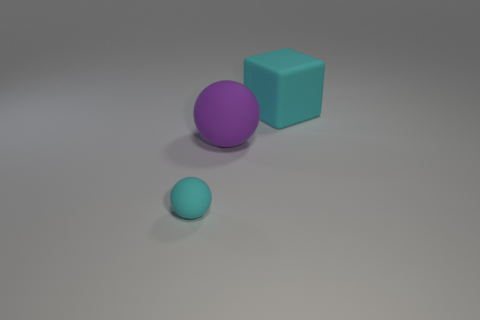Add 3 large cyan blocks. How many objects exist? 6 Subtract all cubes. How many objects are left? 2 Subtract all large spheres. Subtract all cyan matte balls. How many objects are left? 1 Add 2 large rubber spheres. How many large rubber spheres are left? 3 Add 3 red objects. How many red objects exist? 3 Subtract 0 green cubes. How many objects are left? 3 